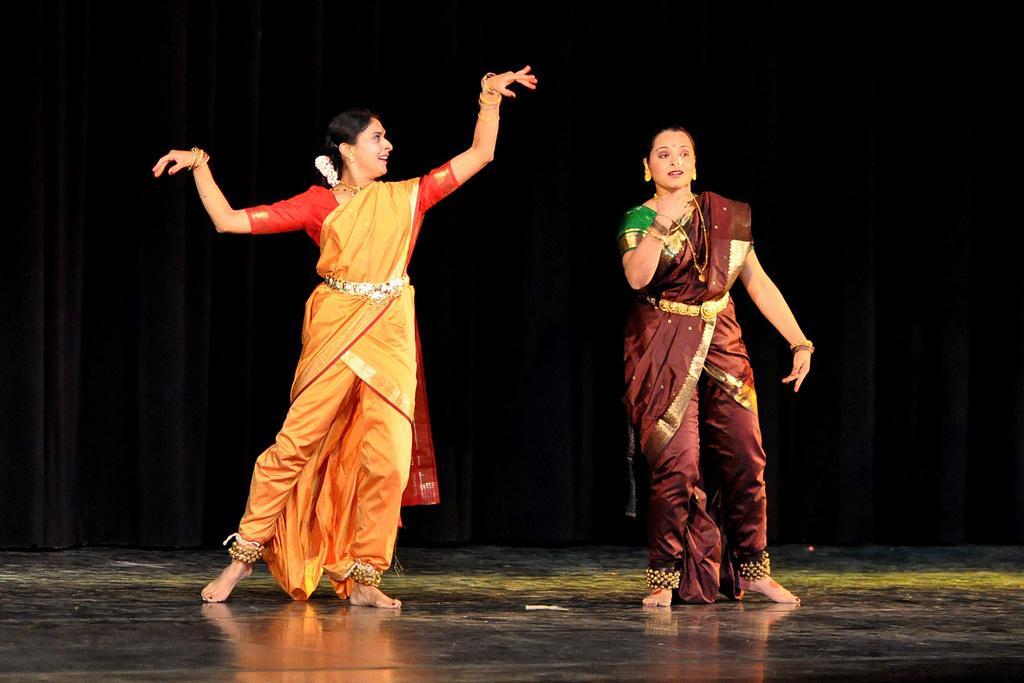Describe this image in one or two sentences. This picture is clicked inside. On the right there is a woman wearing brown color saree and standing on the ground seems to be dancing. On the left there is another woman wearing yellow color saree and standing on the ground and seems to be dancing. In the background we can see the curtains. 